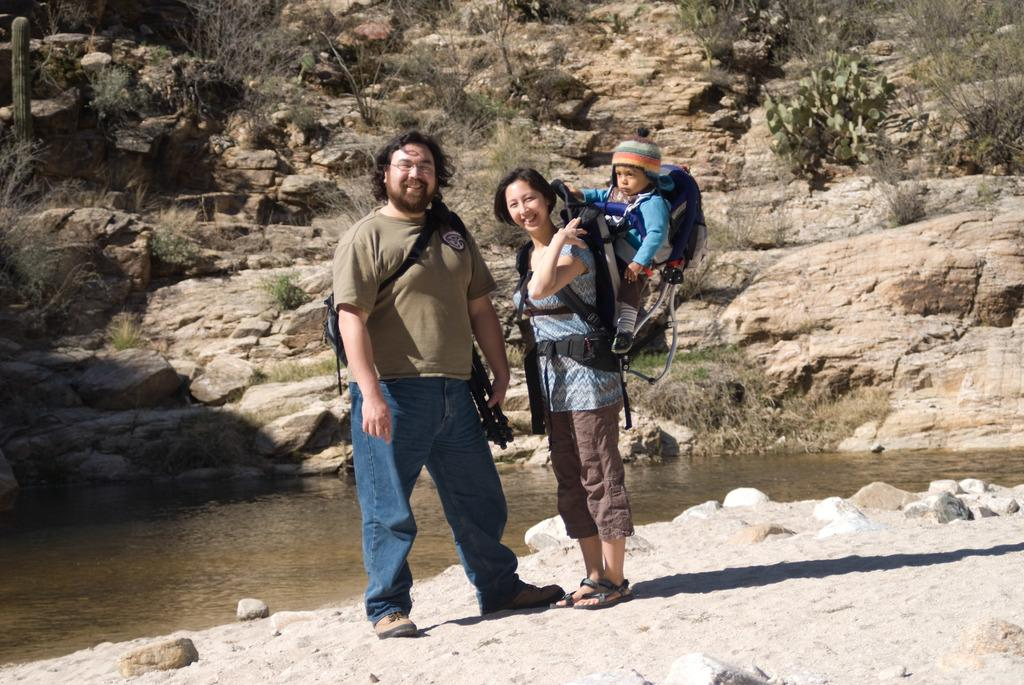How many people are present in the image? There are three people in the image: a man, a girl, and a baby. What can be seen in the background of the image? In the background of the image, there is water, stones, and trees. What might be the relationship between the man and the girl in the image? It is not possible to determine the exact relationship between the man and the girl from the image alone. What type of scarf is the baby wearing in the image? There is no scarf visible on the baby in the image. Where is the lunchroom located in the image? There is no lunchroom present in the image. What type of cloud can be seen in the image? There are no clouds visible in the image. 